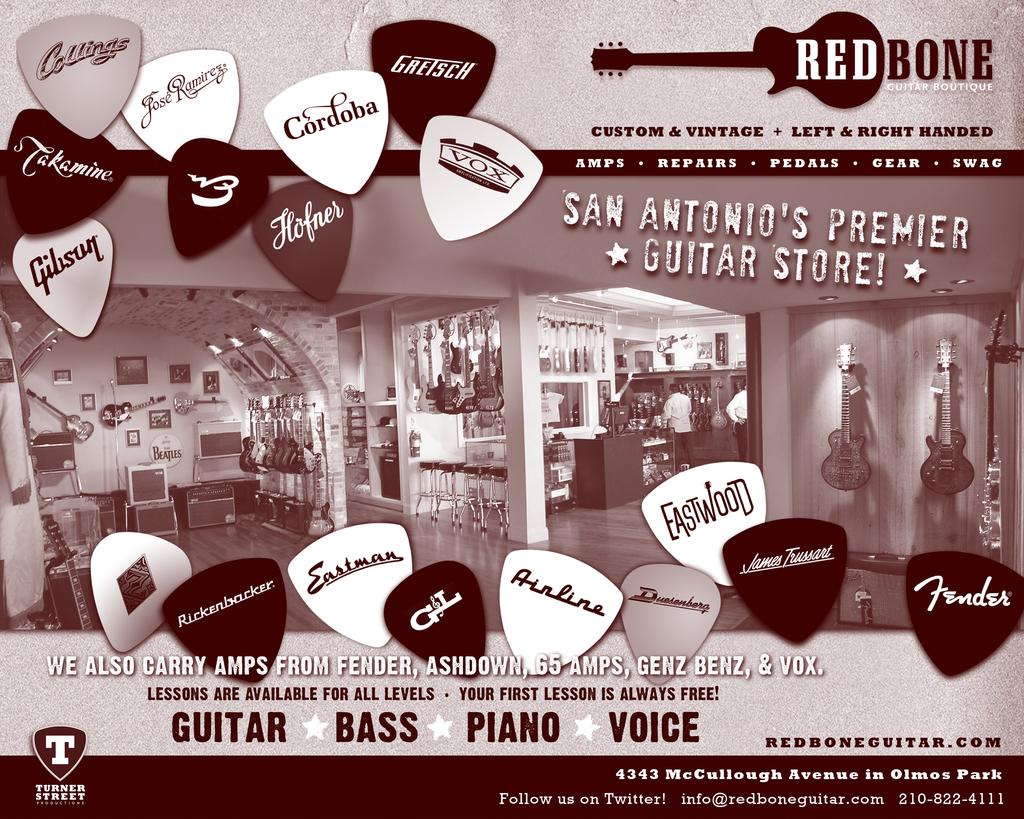What is featured in the image? There is a poster in the image. What is the subject of the poster? The poster depicts a musical instrument shop. What type of musical instruments can be seen in the shop? The shop contains many guitars and other musical instruments. What color is the ear on the poster? There is no ear present on the poster; it depicts a musical instrument shop. 